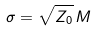<formula> <loc_0><loc_0><loc_500><loc_500>\sigma = \sqrt { Z _ { 0 } } \, M</formula> 